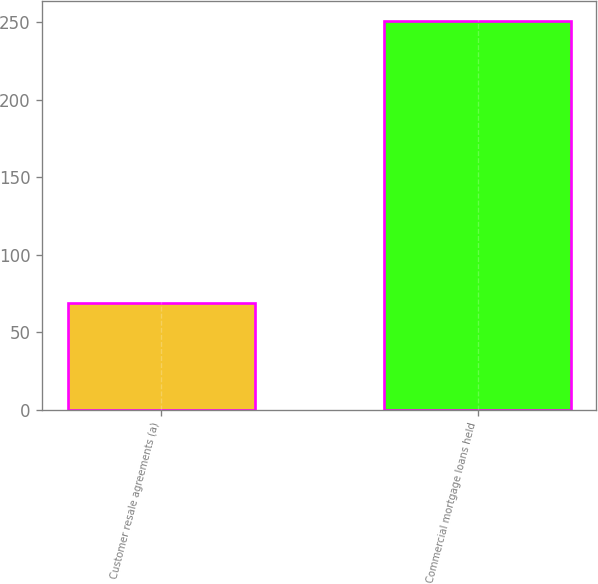<chart> <loc_0><loc_0><loc_500><loc_500><bar_chart><fcel>Customer resale agreements (a)<fcel>Commercial mortgage loans held<nl><fcel>69<fcel>251<nl></chart> 